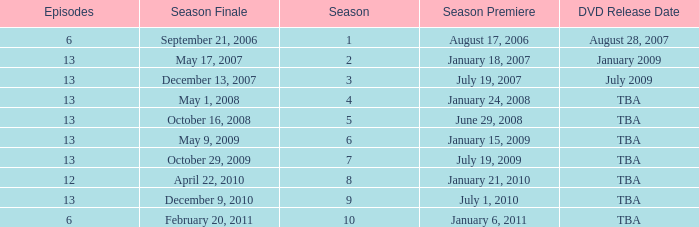On what date was the DVD released for the season with fewer than 13 episodes that aired before season 8? August 28, 2007. 